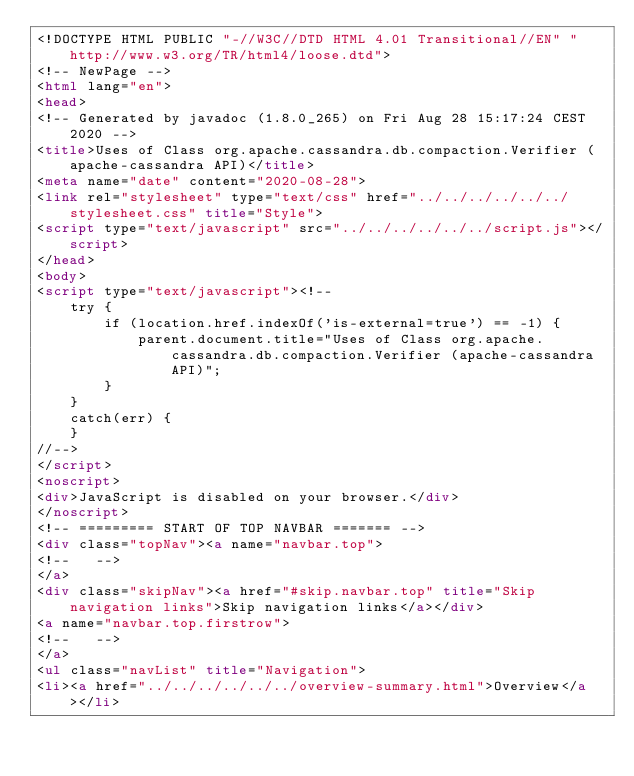<code> <loc_0><loc_0><loc_500><loc_500><_HTML_><!DOCTYPE HTML PUBLIC "-//W3C//DTD HTML 4.01 Transitional//EN" "http://www.w3.org/TR/html4/loose.dtd">
<!-- NewPage -->
<html lang="en">
<head>
<!-- Generated by javadoc (1.8.0_265) on Fri Aug 28 15:17:24 CEST 2020 -->
<title>Uses of Class org.apache.cassandra.db.compaction.Verifier (apache-cassandra API)</title>
<meta name="date" content="2020-08-28">
<link rel="stylesheet" type="text/css" href="../../../../../../stylesheet.css" title="Style">
<script type="text/javascript" src="../../../../../../script.js"></script>
</head>
<body>
<script type="text/javascript"><!--
    try {
        if (location.href.indexOf('is-external=true') == -1) {
            parent.document.title="Uses of Class org.apache.cassandra.db.compaction.Verifier (apache-cassandra API)";
        }
    }
    catch(err) {
    }
//-->
</script>
<noscript>
<div>JavaScript is disabled on your browser.</div>
</noscript>
<!-- ========= START OF TOP NAVBAR ======= -->
<div class="topNav"><a name="navbar.top">
<!--   -->
</a>
<div class="skipNav"><a href="#skip.navbar.top" title="Skip navigation links">Skip navigation links</a></div>
<a name="navbar.top.firstrow">
<!--   -->
</a>
<ul class="navList" title="Navigation">
<li><a href="../../../../../../overview-summary.html">Overview</a></li></code> 